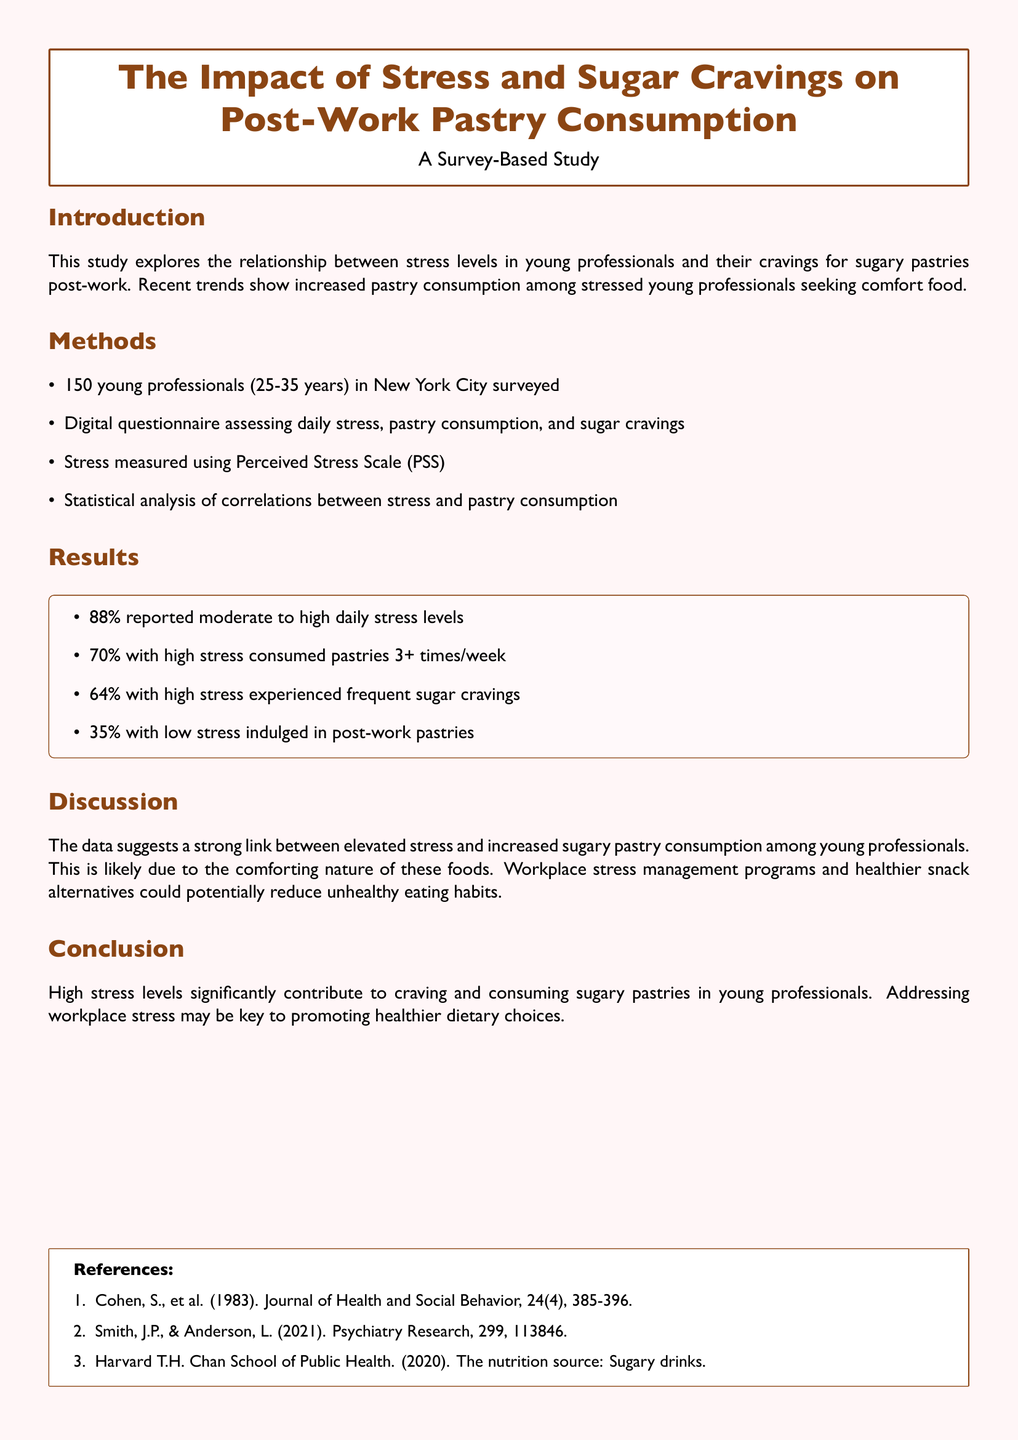What was the sample size of the survey? The sample size is stated in the Methods section and is 150 young professionals.
Answer: 150 What percentage of participants reported high daily stress levels? This information is found in the Results section, specifically stating that 88% reported moderate to high daily stress levels.
Answer: 88% How often did 70% of high-stress individuals consume pastries? This statistic is in the Results section, indicating they consumed pastries 3 or more times a week.
Answer: 3+ times/week What measurement tool was used for assessing stress levels? The Methods section describes the Perceived Stress Scale (PSS) as the tool used.
Answer: Perceived Stress Scale (PSS) What could potentially reduce unhealthy eating habits according to the Discussion? The Discussion section recommends workplace stress management programs as a possible solution.
Answer: Workplace stress management programs Why might young professionals turn to sugary pastries after work? In the Discussion, it's suggested that these foods are comforting.
Answer: Comforting nature What is the age range of participants in the study? This detail is provided in the Methods section, indicating the age range is between 25 to 35 years.
Answer: 25-35 years What is the overall conclusion of the study? The Conclusion section states that high stress levels significantly contribute to craving and consuming sugary pastries.
Answer: High stress levels significantly contribute to craving and consuming sugary pastries 